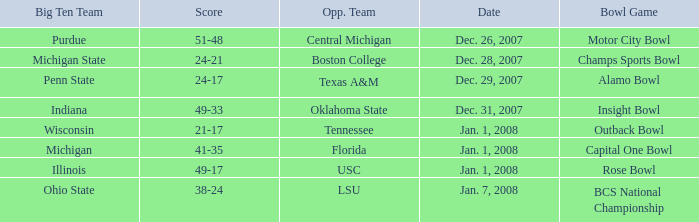What was the outcome of the insight bowl? 49-33. 